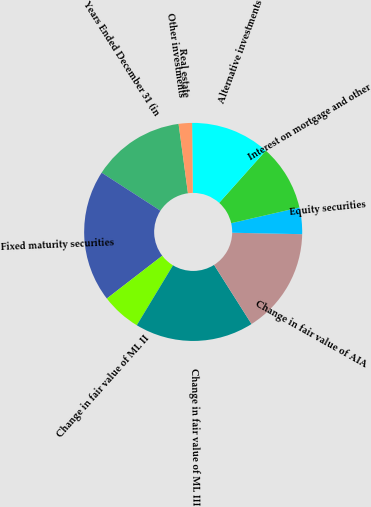<chart> <loc_0><loc_0><loc_500><loc_500><pie_chart><fcel>Years Ended December 31 (in<fcel>Fixed maturity securities<fcel>Change in fair value of ML II<fcel>Change in fair value of ML III<fcel>Change in fair value of AIA<fcel>Equity securities<fcel>Interest on mortgage and other<fcel>Alternative investments<fcel>Real estate<fcel>Other investments<nl><fcel>13.72%<fcel>19.6%<fcel>5.89%<fcel>17.64%<fcel>15.68%<fcel>3.93%<fcel>9.8%<fcel>11.76%<fcel>1.97%<fcel>0.01%<nl></chart> 